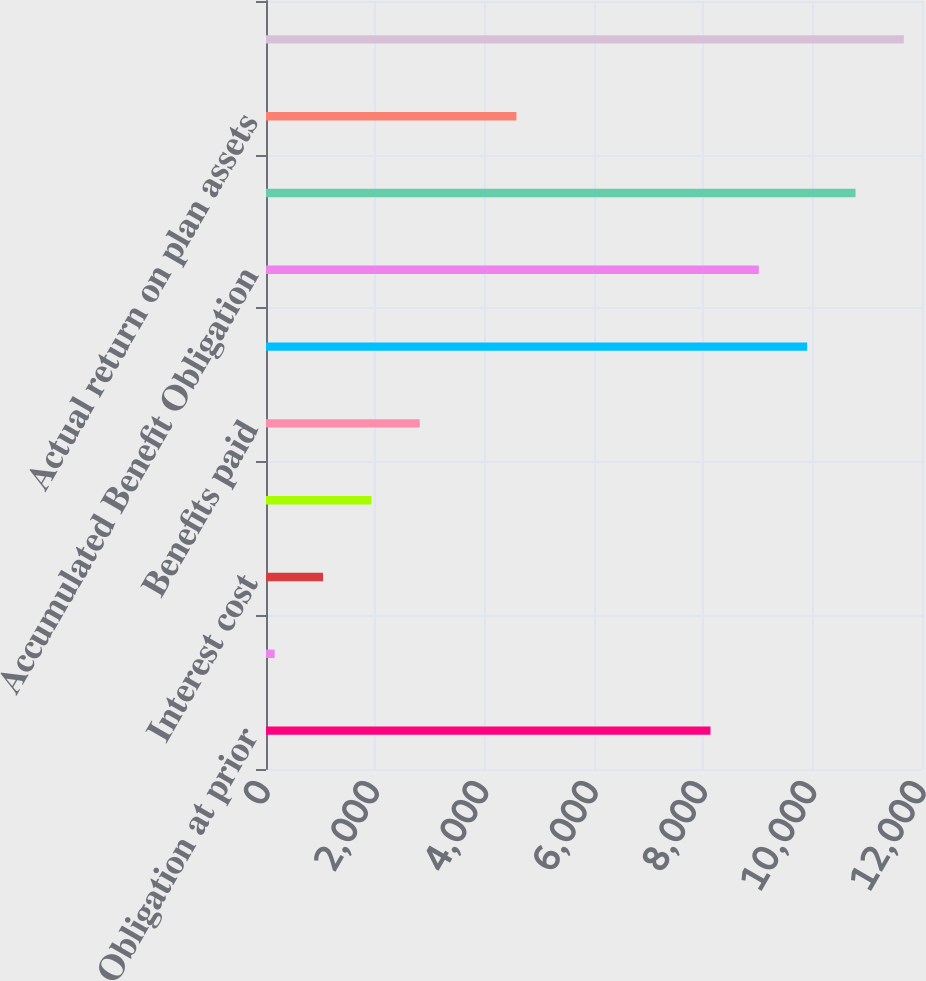<chart> <loc_0><loc_0><loc_500><loc_500><bar_chart><fcel>Obligation at prior<fcel>Service cost<fcel>Interest cost<fcel>Actuarial loss<fcel>Benefits paid<fcel>Obligation at measurement date<fcel>Accumulated Benefit Obligation<fcel>Plan assets at prior<fcel>Actual return on plan assets<fcel>Plan assets at measurement<nl><fcel>8131<fcel>159<fcel>1043.4<fcel>1927.8<fcel>2812.2<fcel>9899.8<fcel>9015.4<fcel>10784.2<fcel>4581<fcel>11668.6<nl></chart> 